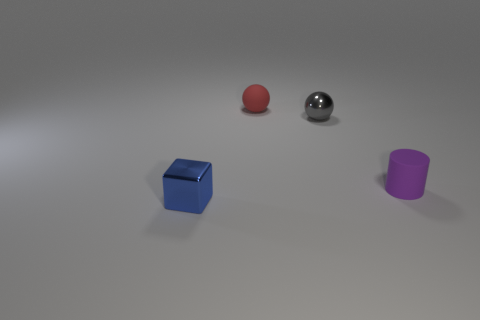Is there anything else that is the same shape as the tiny purple matte object?
Provide a short and direct response. No. There is a object behind the shiny ball; is its shape the same as the small gray metallic thing?
Ensure brevity in your answer.  Yes. Are there more red things in front of the gray sphere than big yellow rubber things?
Ensure brevity in your answer.  No. How many tiny objects are both left of the gray shiny sphere and behind the tiny purple object?
Your response must be concise. 1. The metal thing that is to the right of the small rubber thing on the left side of the purple cylinder is what color?
Keep it short and to the point. Gray. How many small cylinders have the same color as the small shiny block?
Offer a terse response. 0. There is a rubber ball; is its color the same as the tiny object that is in front of the purple cylinder?
Keep it short and to the point. No. Is the number of big red rubber things less than the number of blue cubes?
Keep it short and to the point. Yes. Is the number of metallic balls that are behind the matte ball greater than the number of balls that are in front of the cube?
Make the answer very short. No. Do the red sphere and the small cylinder have the same material?
Your response must be concise. Yes. 